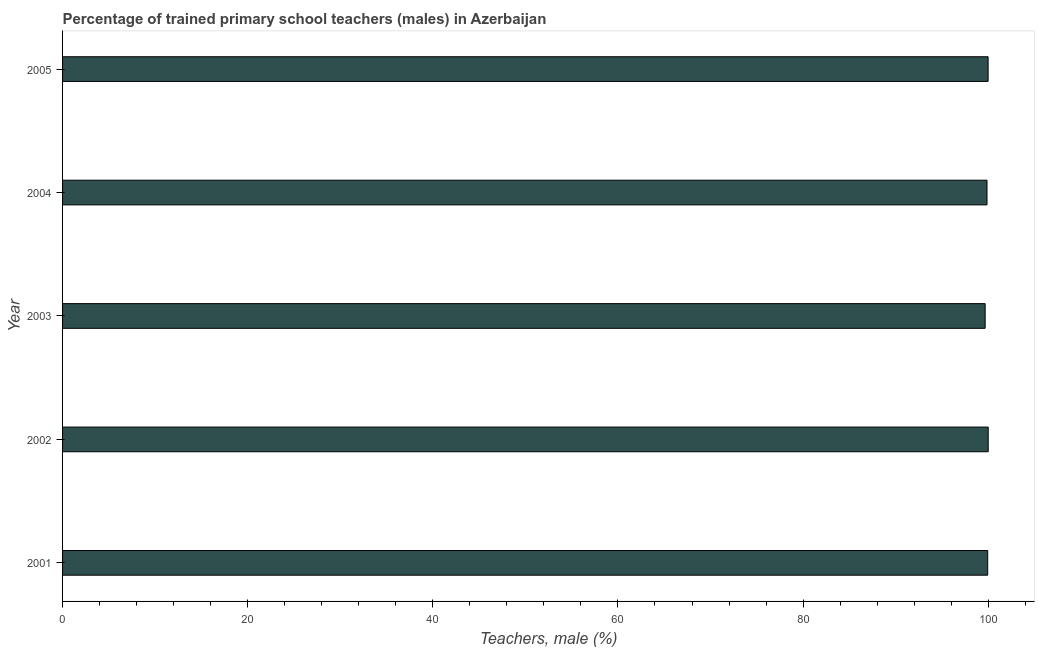What is the title of the graph?
Your answer should be very brief. Percentage of trained primary school teachers (males) in Azerbaijan. What is the label or title of the X-axis?
Give a very brief answer. Teachers, male (%). Across all years, what is the maximum percentage of trained male teachers?
Give a very brief answer. 100. Across all years, what is the minimum percentage of trained male teachers?
Offer a terse response. 99.67. In which year was the percentage of trained male teachers minimum?
Offer a very short reply. 2003. What is the sum of the percentage of trained male teachers?
Your answer should be very brief. 499.47. What is the difference between the percentage of trained male teachers in 2002 and 2004?
Your answer should be compact. 0.13. What is the average percentage of trained male teachers per year?
Offer a terse response. 99.89. What is the median percentage of trained male teachers?
Keep it short and to the point. 99.94. In how many years, is the percentage of trained male teachers greater than 76 %?
Offer a terse response. 5. Do a majority of the years between 2002 and 2003 (inclusive) have percentage of trained male teachers greater than 56 %?
Provide a short and direct response. Yes. What is the ratio of the percentage of trained male teachers in 2004 to that in 2005?
Your response must be concise. 1. Is the difference between the percentage of trained male teachers in 2001 and 2003 greater than the difference between any two years?
Make the answer very short. No. What is the difference between the highest and the second highest percentage of trained male teachers?
Make the answer very short. 0.01. What is the difference between the highest and the lowest percentage of trained male teachers?
Offer a very short reply. 0.33. In how many years, is the percentage of trained male teachers greater than the average percentage of trained male teachers taken over all years?
Keep it short and to the point. 3. How many bars are there?
Give a very brief answer. 5. Are all the bars in the graph horizontal?
Provide a succinct answer. Yes. What is the difference between two consecutive major ticks on the X-axis?
Give a very brief answer. 20. What is the Teachers, male (%) of 2001?
Offer a terse response. 99.94. What is the Teachers, male (%) in 2002?
Give a very brief answer. 100. What is the Teachers, male (%) in 2003?
Make the answer very short. 99.67. What is the Teachers, male (%) of 2004?
Offer a terse response. 99.87. What is the Teachers, male (%) in 2005?
Offer a very short reply. 99.99. What is the difference between the Teachers, male (%) in 2001 and 2002?
Ensure brevity in your answer.  -0.06. What is the difference between the Teachers, male (%) in 2001 and 2003?
Your answer should be very brief. 0.27. What is the difference between the Teachers, male (%) in 2001 and 2004?
Give a very brief answer. 0.07. What is the difference between the Teachers, male (%) in 2001 and 2005?
Your answer should be compact. -0.04. What is the difference between the Teachers, male (%) in 2002 and 2003?
Provide a succinct answer. 0.33. What is the difference between the Teachers, male (%) in 2002 and 2004?
Provide a short and direct response. 0.13. What is the difference between the Teachers, male (%) in 2002 and 2005?
Offer a very short reply. 0.01. What is the difference between the Teachers, male (%) in 2003 and 2004?
Offer a very short reply. -0.2. What is the difference between the Teachers, male (%) in 2003 and 2005?
Your answer should be compact. -0.32. What is the difference between the Teachers, male (%) in 2004 and 2005?
Your answer should be very brief. -0.12. What is the ratio of the Teachers, male (%) in 2001 to that in 2002?
Ensure brevity in your answer.  1. What is the ratio of the Teachers, male (%) in 2001 to that in 2005?
Your answer should be compact. 1. What is the ratio of the Teachers, male (%) in 2002 to that in 2005?
Your response must be concise. 1. What is the ratio of the Teachers, male (%) in 2003 to that in 2005?
Provide a succinct answer. 1. 